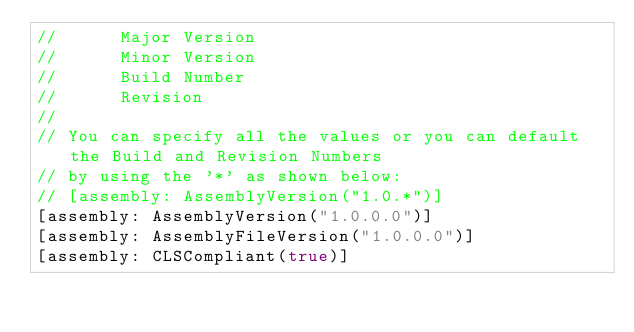<code> <loc_0><loc_0><loc_500><loc_500><_C#_>//      Major Version
//      Minor Version 
//      Build Number
//      Revision
//
// You can specify all the values or you can default the Build and Revision Numbers 
// by using the '*' as shown below:
// [assembly: AssemblyVersion("1.0.*")]
[assembly: AssemblyVersion("1.0.0.0")]
[assembly: AssemblyFileVersion("1.0.0.0")]
[assembly: CLSCompliant(true)]</code> 